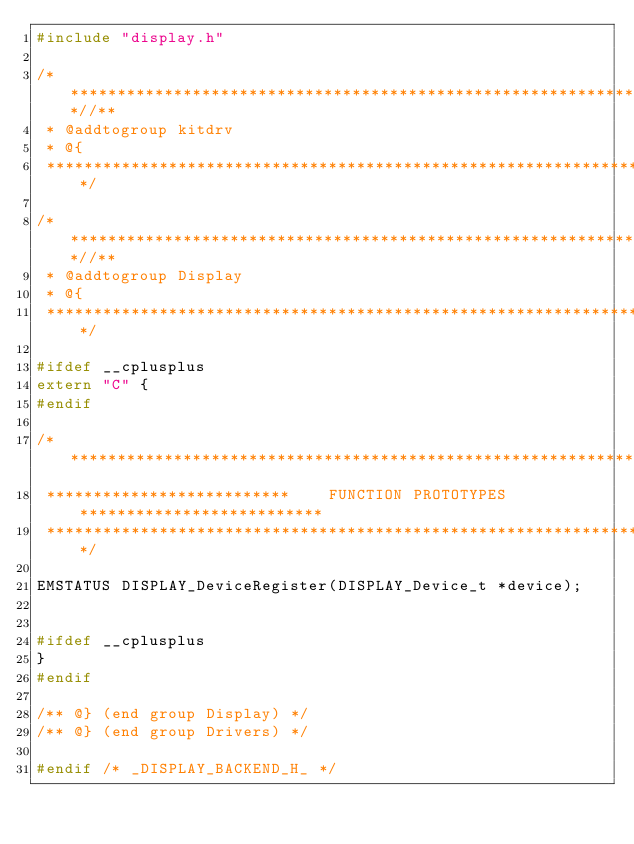<code> <loc_0><loc_0><loc_500><loc_500><_C_>#include "display.h"

/***************************************************************************//**
 * @addtogroup kitdrv
 * @{
 ******************************************************************************/

/***************************************************************************//**
 * @addtogroup Display
 * @{
 ******************************************************************************/

#ifdef __cplusplus
extern "C" {
#endif

/*******************************************************************************
 **************************    FUNCTION PROTOTYPES    **************************
 ******************************************************************************/

EMSTATUS DISPLAY_DeviceRegister(DISPLAY_Device_t *device);


#ifdef __cplusplus
}
#endif

/** @} (end group Display) */
/** @} (end group Drivers) */

#endif /* _DISPLAY_BACKEND_H_ */
</code> 